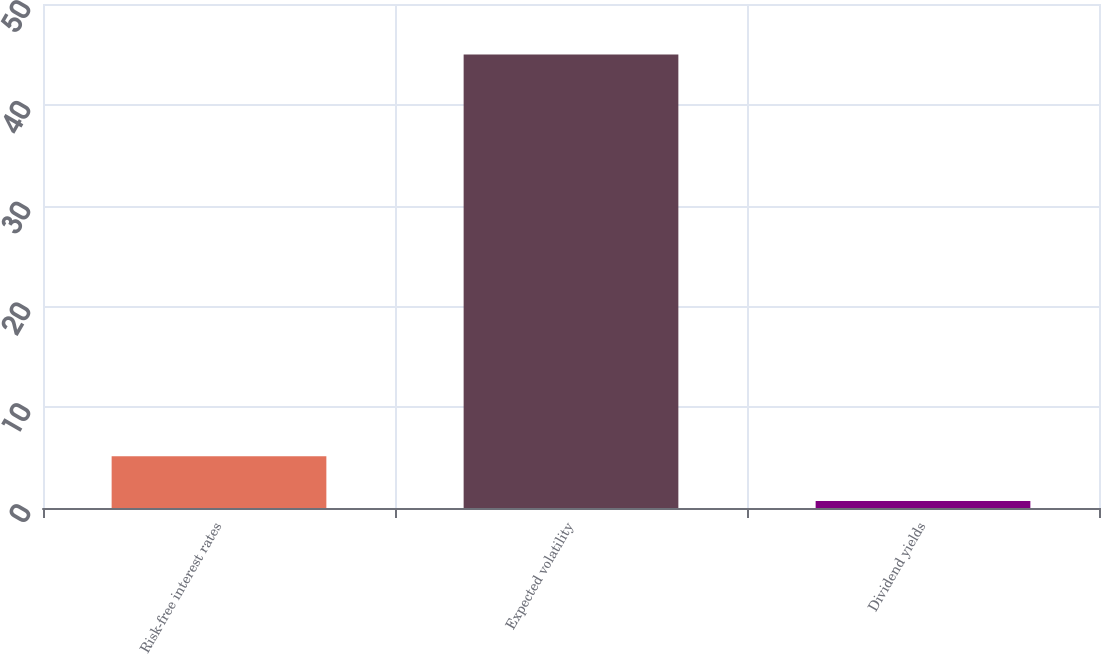Convert chart. <chart><loc_0><loc_0><loc_500><loc_500><bar_chart><fcel>Risk-free interest rates<fcel>Expected volatility<fcel>Dividend yields<nl><fcel>5.13<fcel>45<fcel>0.7<nl></chart> 